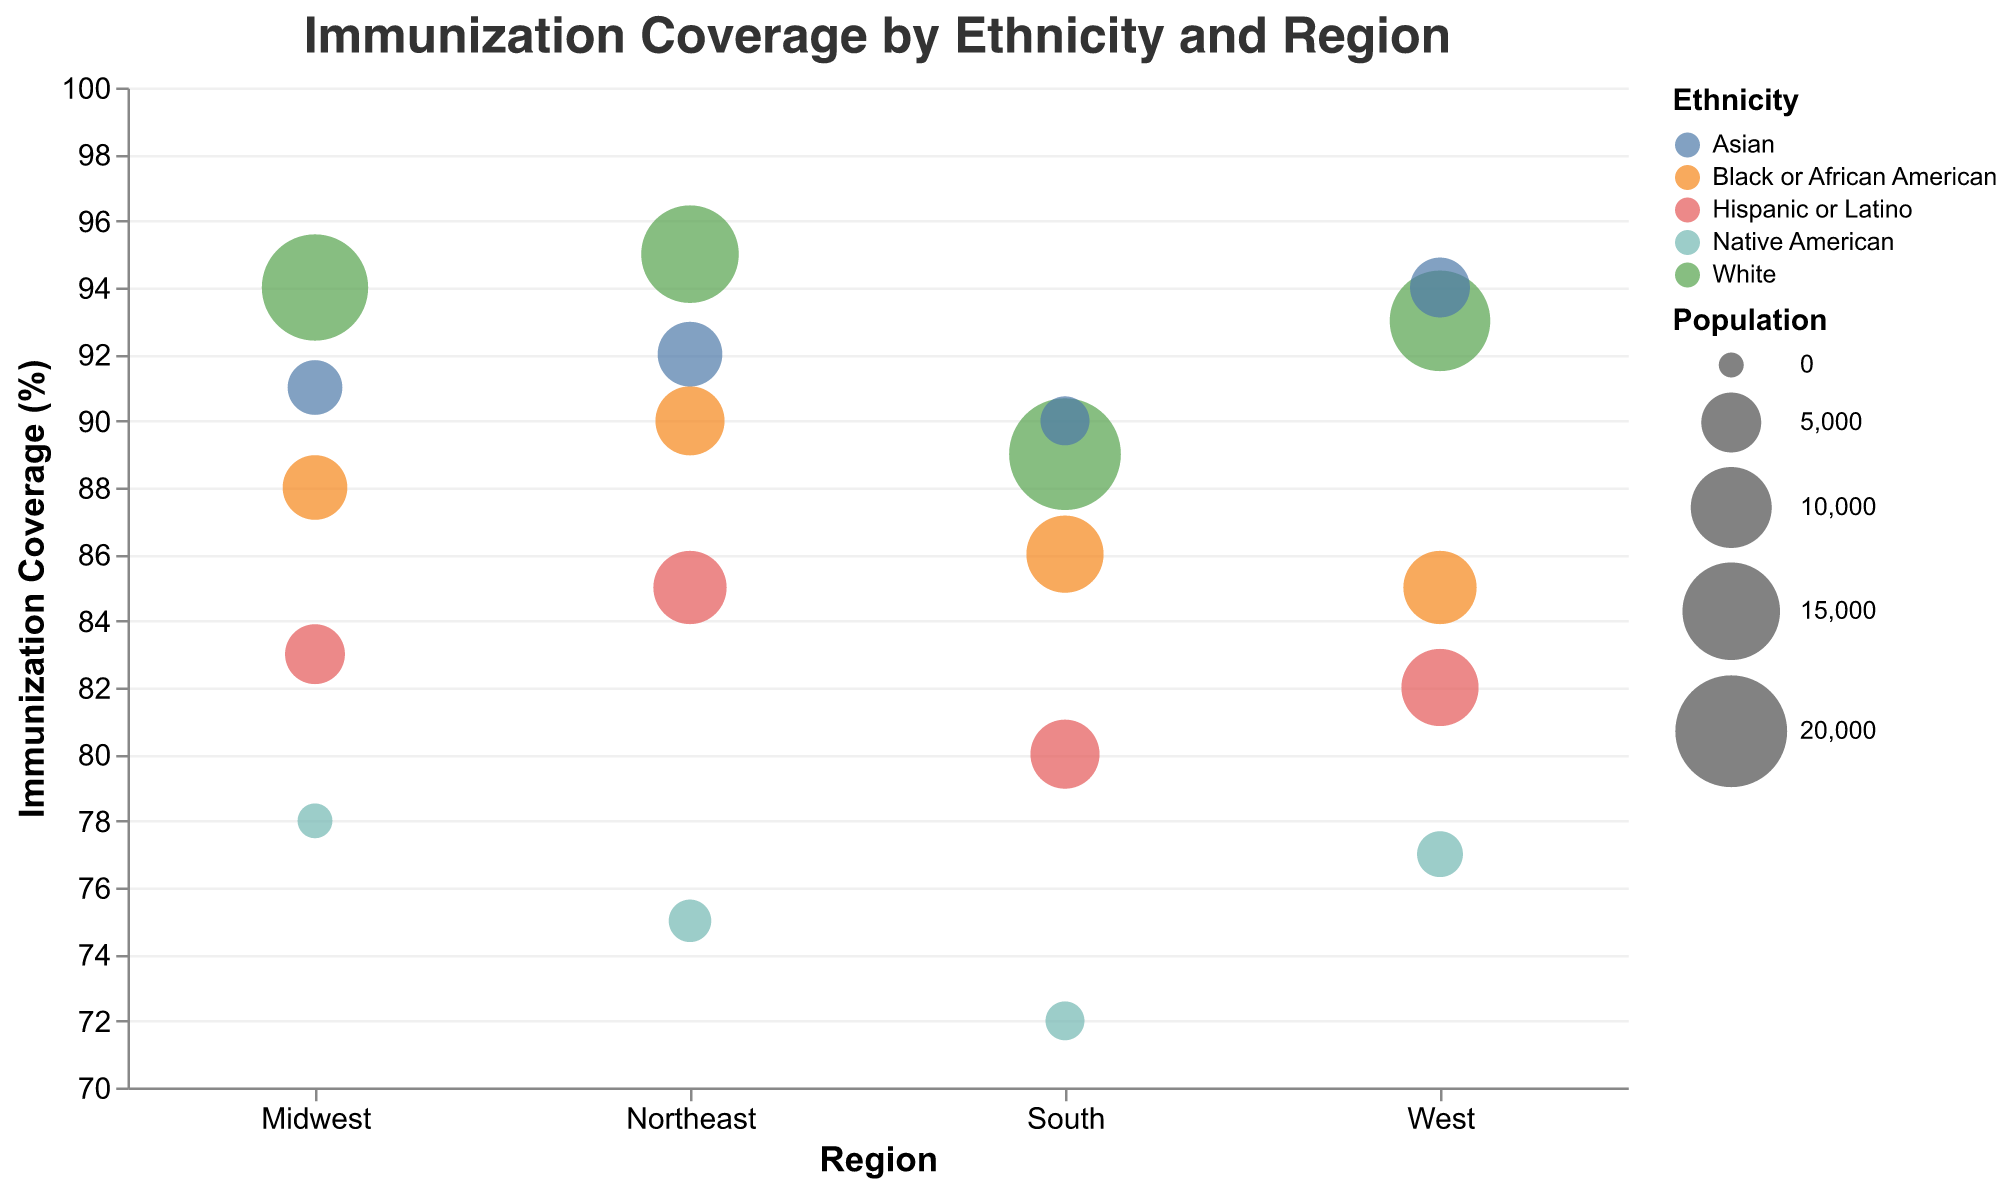What is the title of the figure? The title is displayed at the top center of the figure and reads "Immunization Coverage by Ethnicity and Region".
Answer: Immunization Coverage by Ethnicity and Region What is the immunization coverage percentage for Asian students in the Northeast region? Look at the bubble that represents Asian students in the Northeast region on the chart; the y-axis value of this bubble is the immunization coverage percentage.
Answer: 92% Which ethnic group has the highest immunization coverage in the West? Compare the y-axis values of all bubbles in the West region; the bubble with the highest y-axis value represents the ethnic group with the highest coverage.
Answer: Asian What is the range of the bubble sizes in the figure? The bubble size represents population, defined in the legend; the population ranges from 100 to 2,000.
Answer: 100 to 2,000 How does the immunization coverage for Hispanic or Latino students in the South compare with that in the Northeast? Compare the y-axis values for the Hispanic or Latino students in the South and Northeast regions on the graph.
Answer: The South has 80%, the Northeast has 85% Which region has the lowest immunization coverage for Native American students? Compare the y-axis values of bubbles representing Native American students across all regions.
Answer: South What's the difference in immunization coverage between White students in the Northeast and the Midwest? Find the y-axis values for White students in the Northeast and the Midwest, then subtract the Midwest value from the Northeast value: 95 - 94.
Answer: 1% Which ethnic group in the South region has a population under 3,000? Examine the sizes of the bubbles in the South region and refer to the legend to find the ethnic group with a bubble size corresponding to a population under 3,000.
Answer: Asian What is the average immunization coverage for Hispanic or Latino students across all regions? Find the y-axis values for Hispanic or Latino students in all regions and calculate the average: (85+83+80+82) / 4.
Answer: 82.5 How many ethnic groups in the Northeast have an immunization coverage below 90%? Count the number of bubbles in the Northeast region with y-axis values below 90%.
Answer: 2 